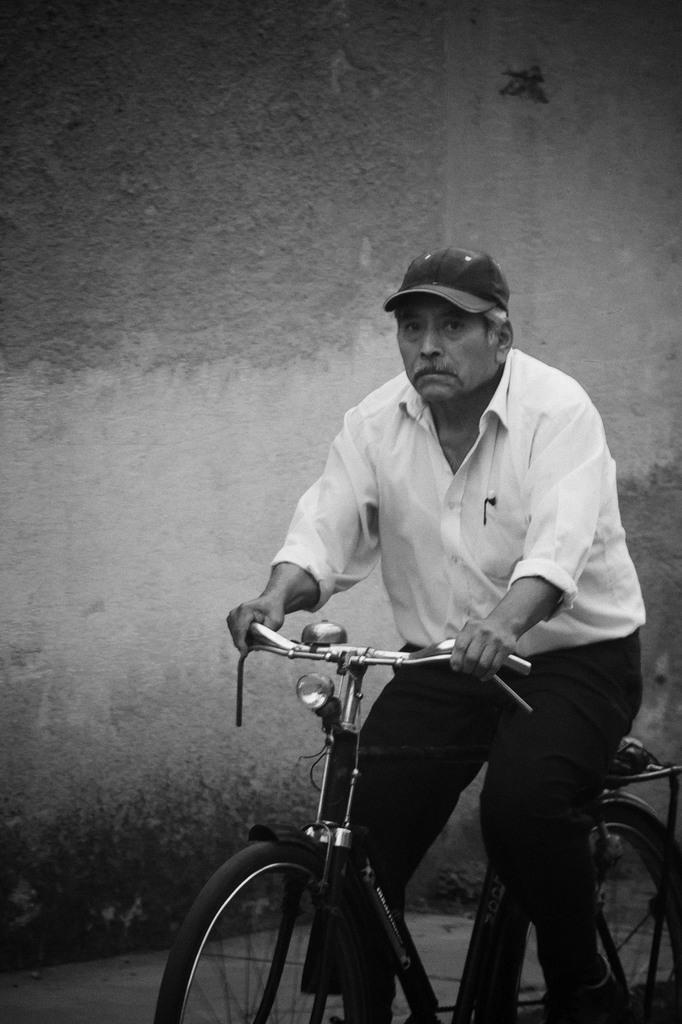What is the main subject of the image? There is a person in the image. What is the person wearing on their head? The person is wearing a hat. What color is the shirt the person is wearing? The person is wearing a white shirt. What color are the pants the person is wearing? The person is wearing black pants. What is the person doing in the image? The person is riding a bicycle. What can be seen in the background of the image? There is a wall in the background of the image. Where is the faucet located in the image? There is no faucet present in the image. How does the person move the bicycle in the image? The person is riding the bicycle, which means they are pedaling and steering the bicycle to move it. 